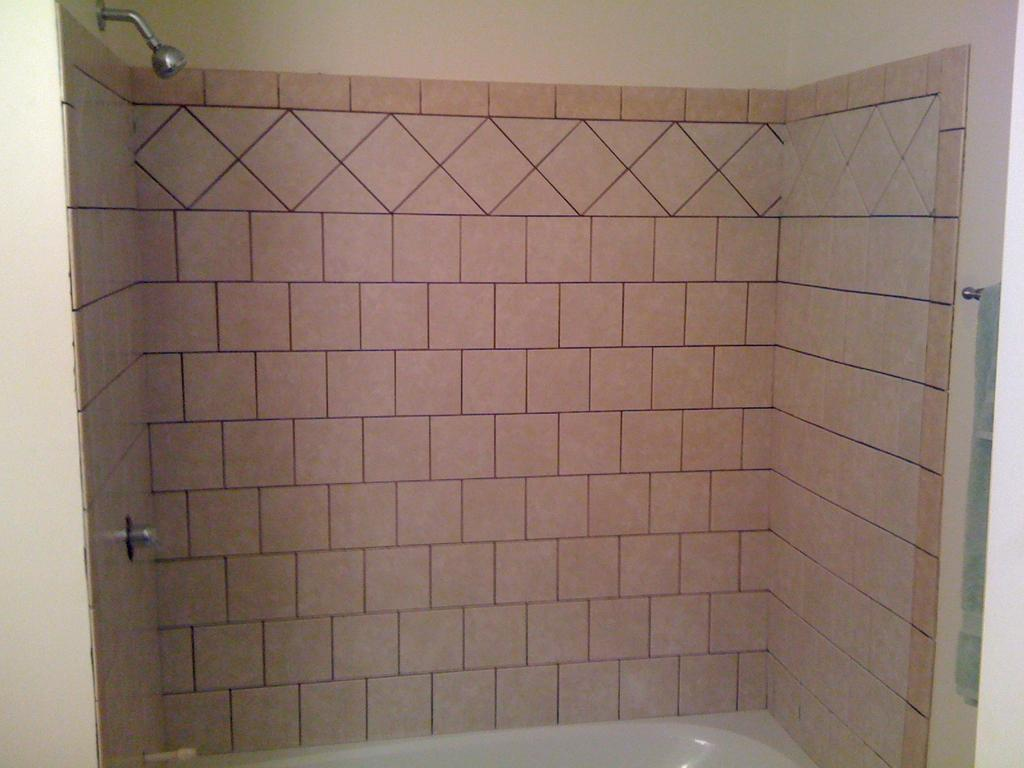What type of structure is present on the wall in the image? There is a brick wall in the image. What can be found on the brick wall? There is a shower and a tap on the wall. What is located at the bottom of the image? There is a bathtub at the bottom of the image. Where is the towel with a hanger in the image? The towel with a hanger is on the left side of the image. What degree of authority does the seat in the image hold? There is no seat present in the image, so the question of authority cannot be addressed. 